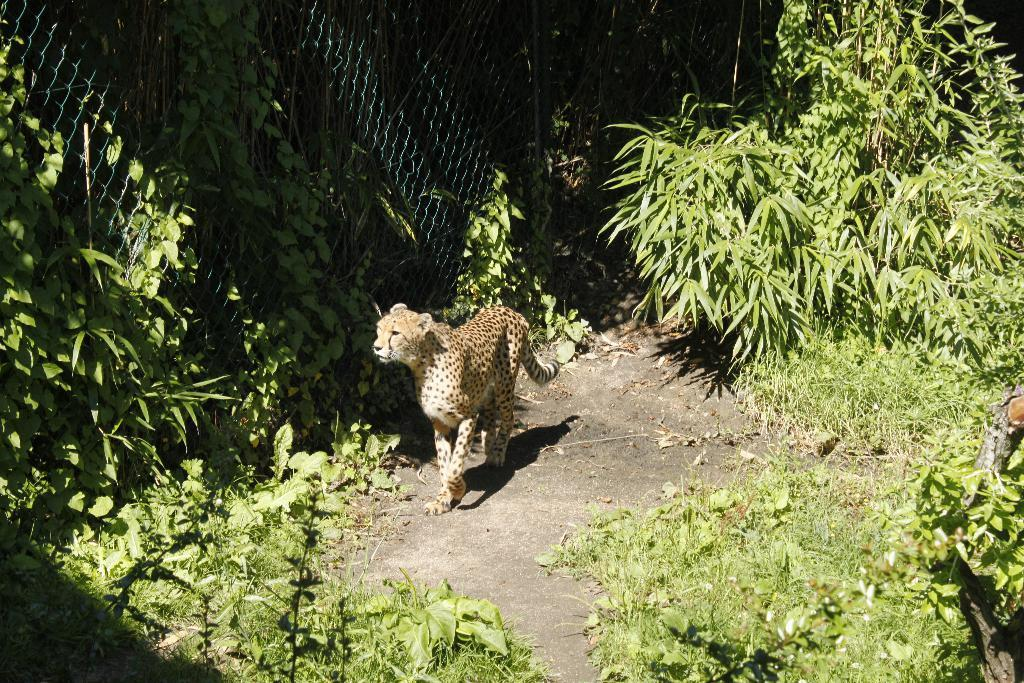What type of animal can be seen in the image? There is an animal in the image, but its specific type cannot be determined from the provided facts. What is the animal doing in the image? The animal is walking on the land in the image. What can be found on the land in the image? There are plants on the land in the image. What is the purpose of the fence in the image? The purpose of the fence in the image is not clear, but it is present. What is growing on the fence in the image? The fence has creeper plants on it in the image. What type of detail can be seen in the middle of the image? There is no specific detail mentioned in the middle of the image, as the provided facts focus on the animal, land, plants, fence, and creeper plants. What type of fork is being used by the animal in the image? There is no fork present in the image, and the animal is walking on the land, not using any utensils. 